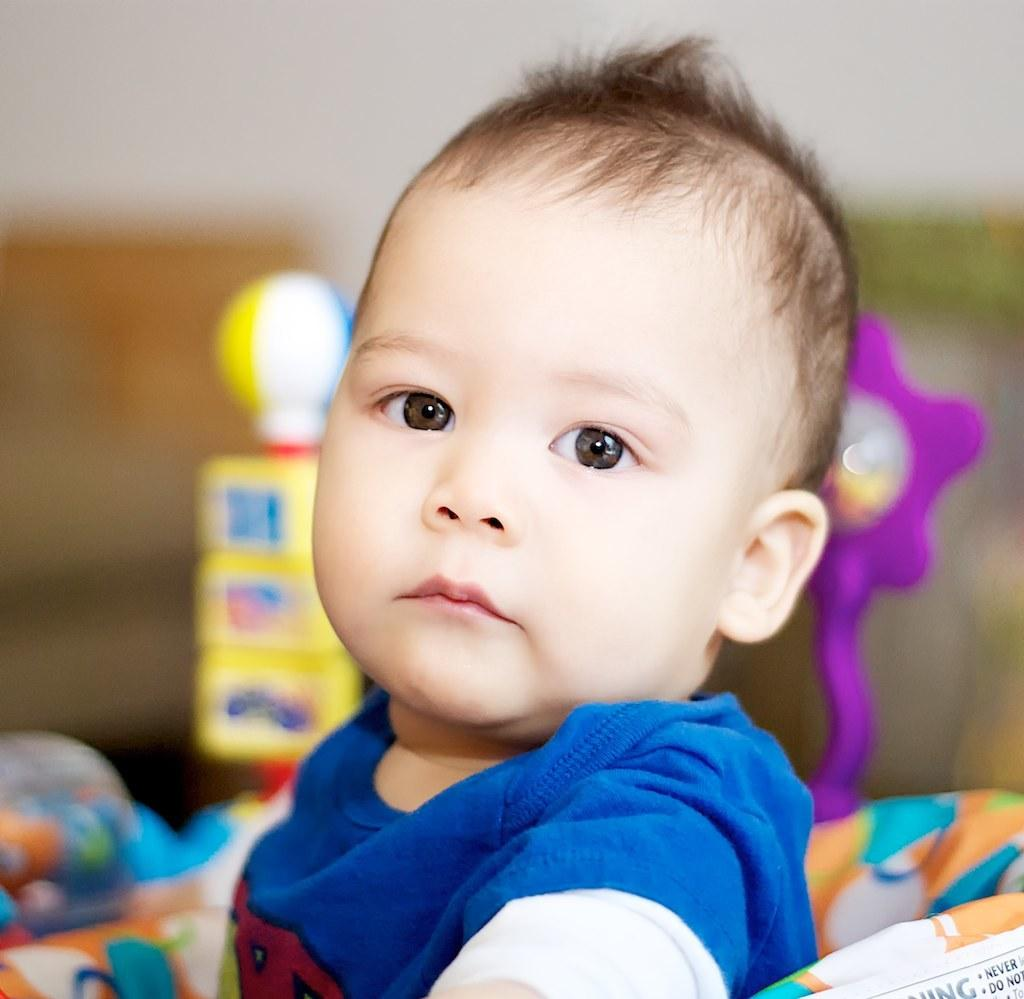What is the main subject of the image? The main subject of the image is a kid. What else can be seen in the image besides the kid? There are toys in the image. Can you describe the background of the image? The background of the image is blurred. What type of whip is being used by the kid in the image? There is no whip present in the image. What kind of structure can be seen in the background of the image? The background of the image is blurred, so it is not possible to identify any structures. 